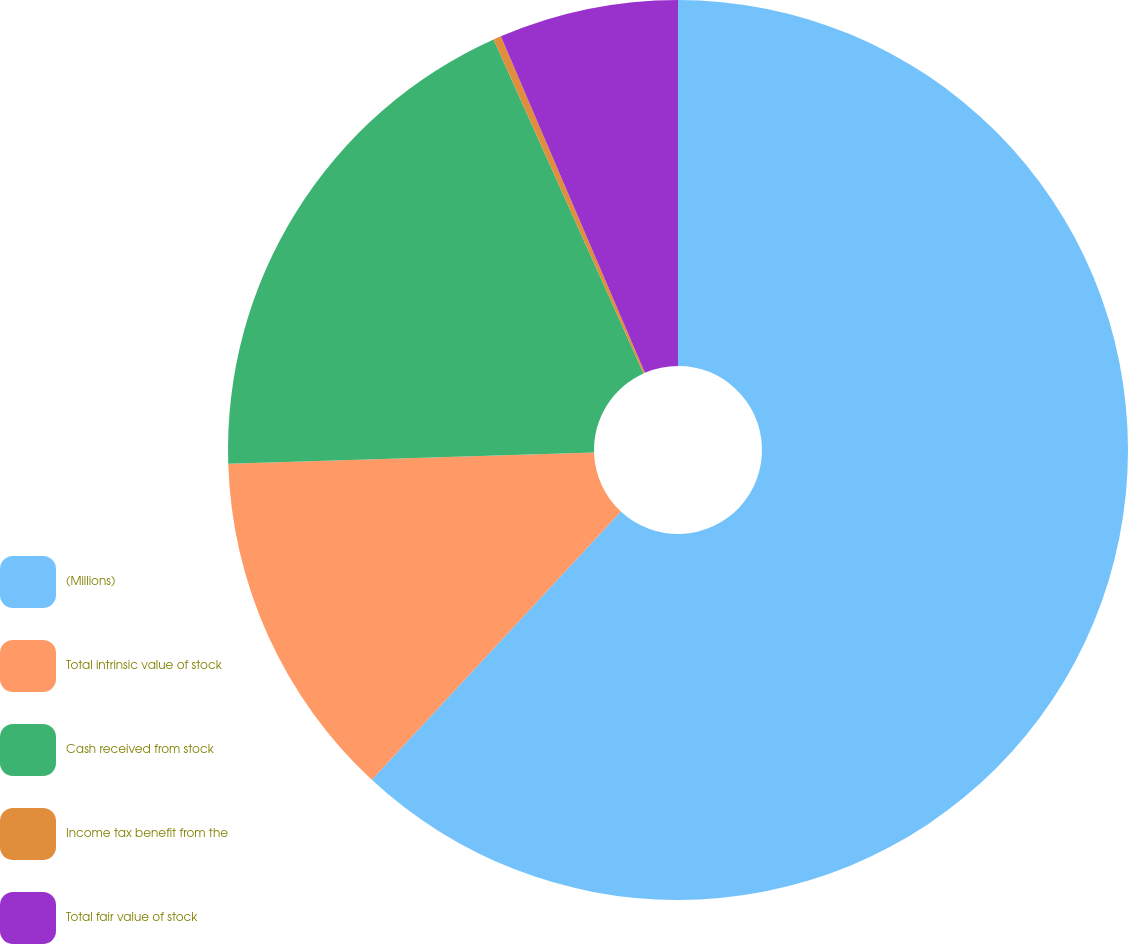Convert chart to OTSL. <chart><loc_0><loc_0><loc_500><loc_500><pie_chart><fcel>(Millions)<fcel>Total intrinsic value of stock<fcel>Cash received from stock<fcel>Income tax benefit from the<fcel>Total fair value of stock<nl><fcel>61.91%<fcel>12.6%<fcel>18.77%<fcel>0.28%<fcel>6.44%<nl></chart> 